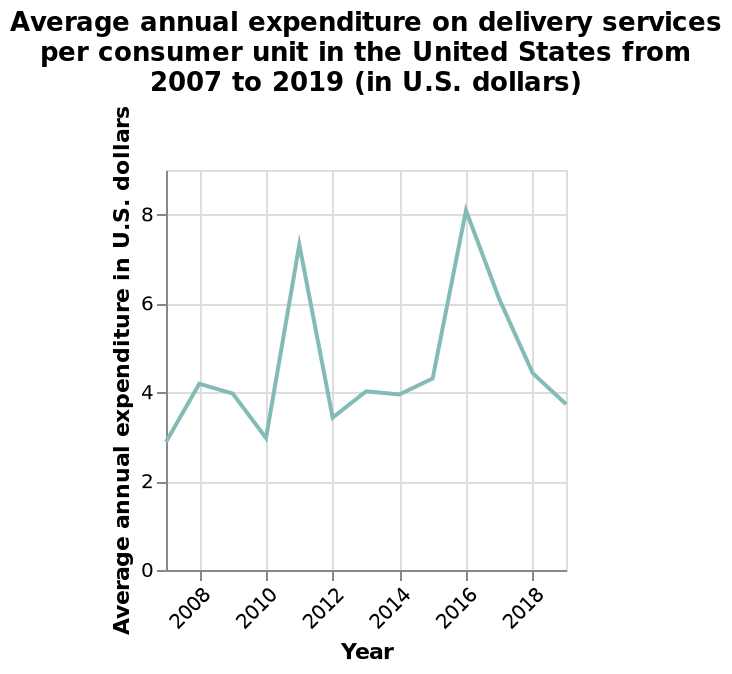<image>
Is there consistency in the utilization of delivery services in America annually? No, the use of delivery services in America varies considerably each year. What is the variation of delivery service usage in America each year? The use of delivery services in America varies considerably each year. What units are used to label the y-axis of the line chart? The y-axis of the line chart is labeled in "Average annual expenditure in U.S. dollars". Are there major differences in the utilization of delivery services from one year to another in America? Yes, the use of delivery services in America varies considerably each year, showcasing significant differences. Does the use of delivery services in America remain unchanged each year? No.No, the use of delivery services in America varies considerably each year. 